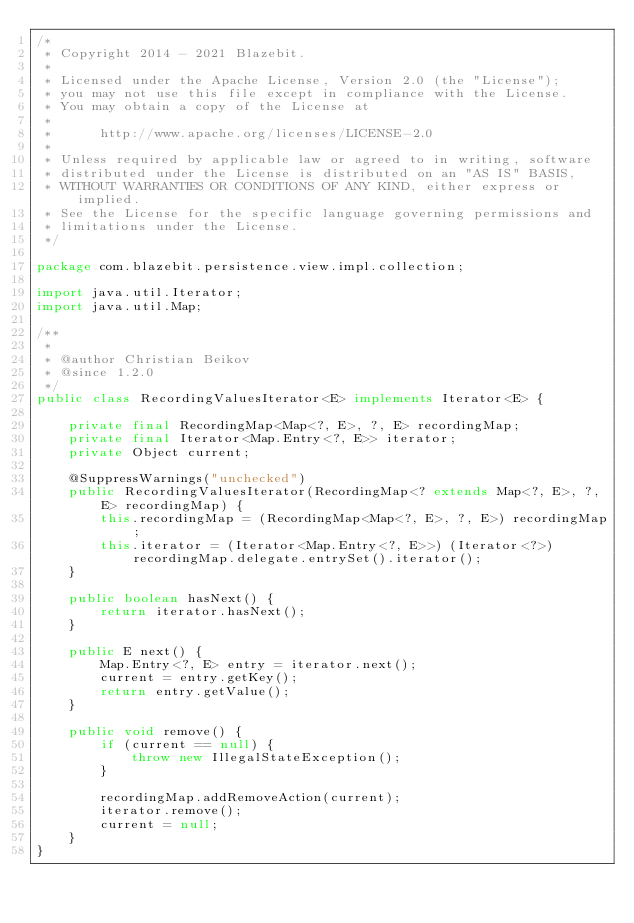Convert code to text. <code><loc_0><loc_0><loc_500><loc_500><_Java_>/*
 * Copyright 2014 - 2021 Blazebit.
 *
 * Licensed under the Apache License, Version 2.0 (the "License");
 * you may not use this file except in compliance with the License.
 * You may obtain a copy of the License at
 *
 *      http://www.apache.org/licenses/LICENSE-2.0
 *
 * Unless required by applicable law or agreed to in writing, software
 * distributed under the License is distributed on an "AS IS" BASIS,
 * WITHOUT WARRANTIES OR CONDITIONS OF ANY KIND, either express or implied.
 * See the License for the specific language governing permissions and
 * limitations under the License.
 */

package com.blazebit.persistence.view.impl.collection;

import java.util.Iterator;
import java.util.Map;

/**
 *
 * @author Christian Beikov
 * @since 1.2.0
 */
public class RecordingValuesIterator<E> implements Iterator<E> {

    private final RecordingMap<Map<?, E>, ?, E> recordingMap;
    private final Iterator<Map.Entry<?, E>> iterator;
    private Object current;

    @SuppressWarnings("unchecked")
    public RecordingValuesIterator(RecordingMap<? extends Map<?, E>, ?, E> recordingMap) {
        this.recordingMap = (RecordingMap<Map<?, E>, ?, E>) recordingMap;
        this.iterator = (Iterator<Map.Entry<?, E>>) (Iterator<?>) recordingMap.delegate.entrySet().iterator();
    }

    public boolean hasNext() {
        return iterator.hasNext();
    }

    public E next() {
        Map.Entry<?, E> entry = iterator.next();
        current = entry.getKey();
        return entry.getValue();
    }

    public void remove() {
        if (current == null) {
            throw new IllegalStateException();
        }

        recordingMap.addRemoveAction(current);
        iterator.remove();
        current = null;
    }
}
</code> 